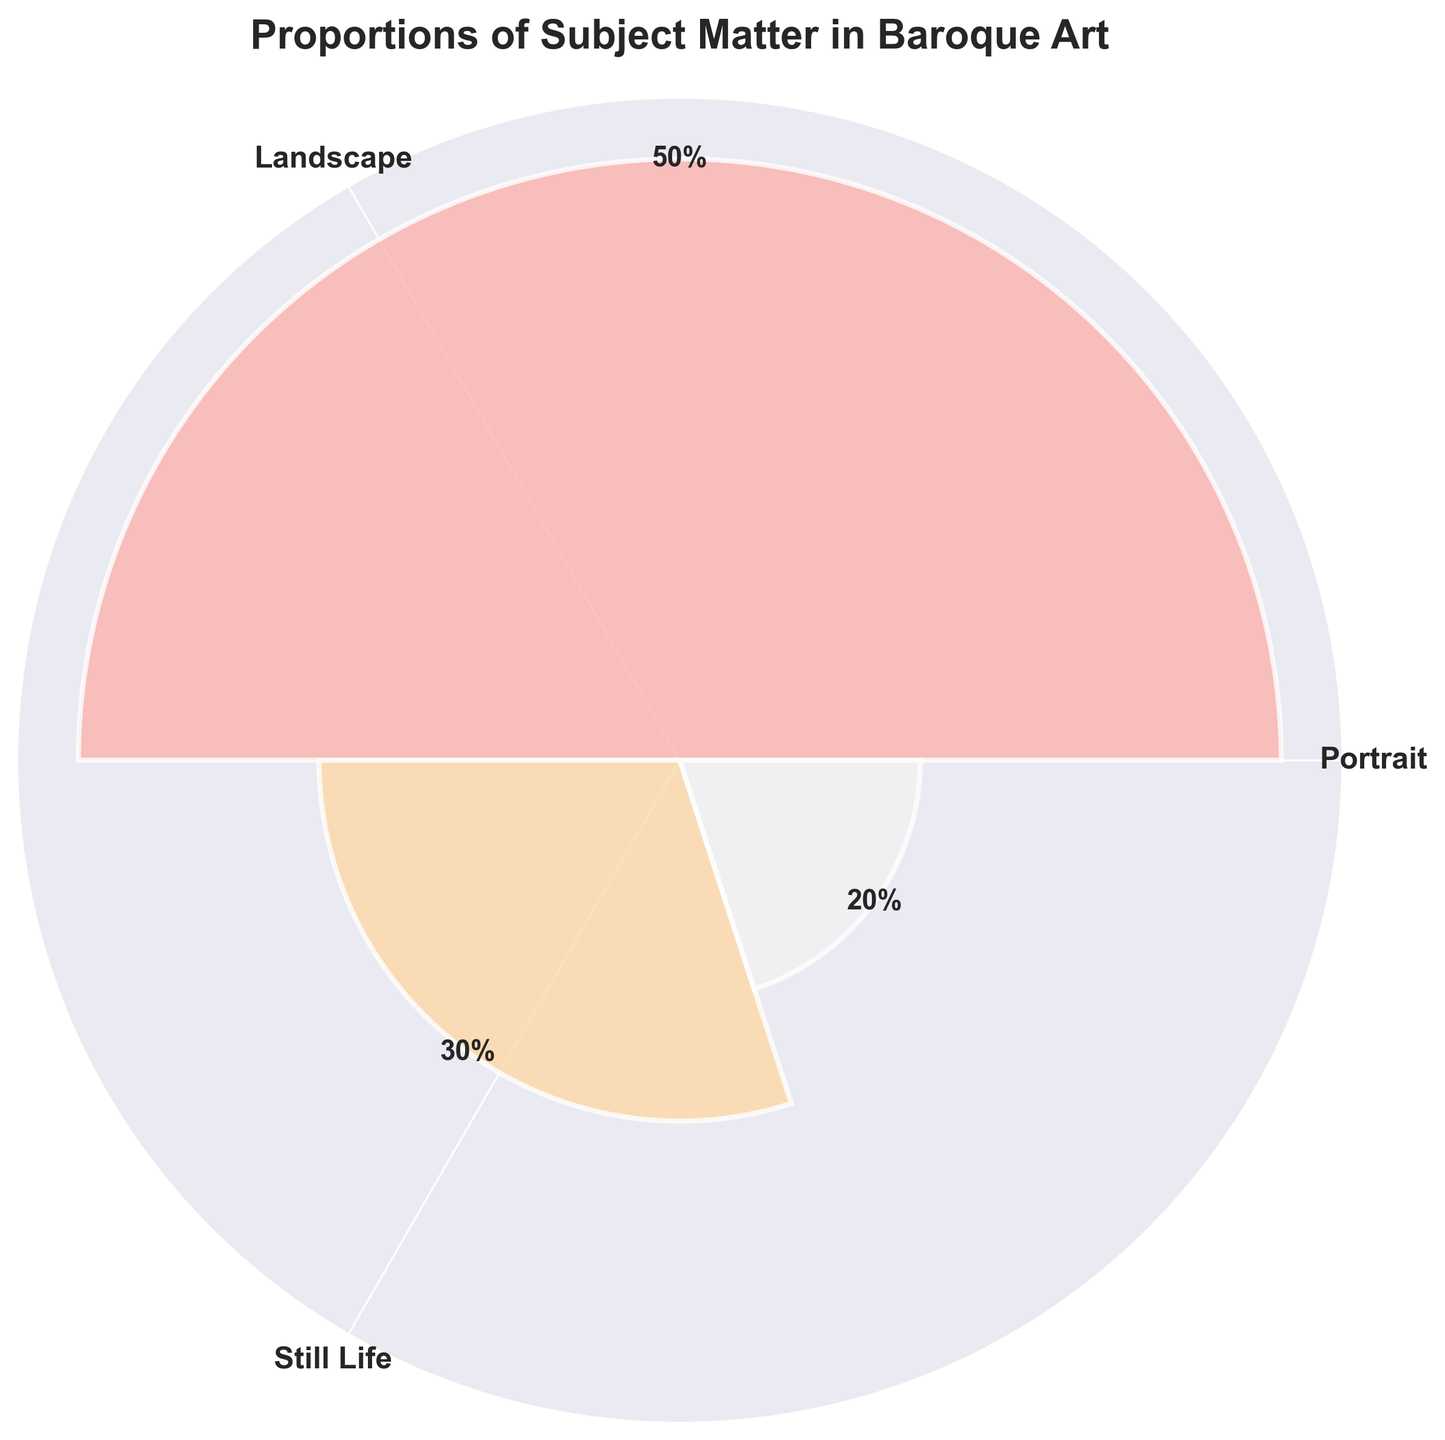What is the title of the chart? The title is located at the top of the chart and provides a description of what the figure represents. The title reads: "Proportions of Subject Matter in Baroque Art"
Answer: Proportions of Subject Matter in Baroque Art How many subject types are displayed in the chart? By examining the labeled slices and the legend, we can count that there are three distinct subject types: Portrait, Landscape, and Still Life
Answer: 3 Which subject matter has the highest proportion? By comparing the heights of the segments, the highest one represents Portrait, indicating it has the highest proportion.
Answer: Portrait What is the proportion of the Landscape subject matter? The text label on the segment for Landscape shows a percentage value. The text states it is 30%.
Answer: 30% Sum up the proportions of Landscape and Still Life. The proportions for Landscape and Still Life are 30% and 20%, respectively. Adding these percentages gives 30% + 20% = 50%.
Answer: 50% How does the proportion of Still Life compare to Landscape? Still Life (20%) has a smaller proportion compared to Landscape (30%), as seen by the segment heights.
Answer: Smaller Are the angles for each subject's segment equal? Inspecting the chart reveals that the segments are of different sizes, corresponding to their different proportions. Hence, the angles for Portrait, Landscape, and Still Life are not equal.
Answer: No What percentage of the chart does Portrait occupies? From the label on the segment representing Portrait, we can see it occupies 50% of the chart.
Answer: 50% How does the largest segment compare to the smallest one in terms of proportion? The largest segment, Portrait, is 50%, while the smallest, Still Life, is 20%. The difference is 50% - 20% = 30%.
Answer: 30% What's the average proportion of the three subject matters? Adding the proportions (50% + 30% + 20%) gives 100%. Dividing this by the number of subject matters (3), the average is 100% / 3 = 33.33%.
Answer: 33.33% 